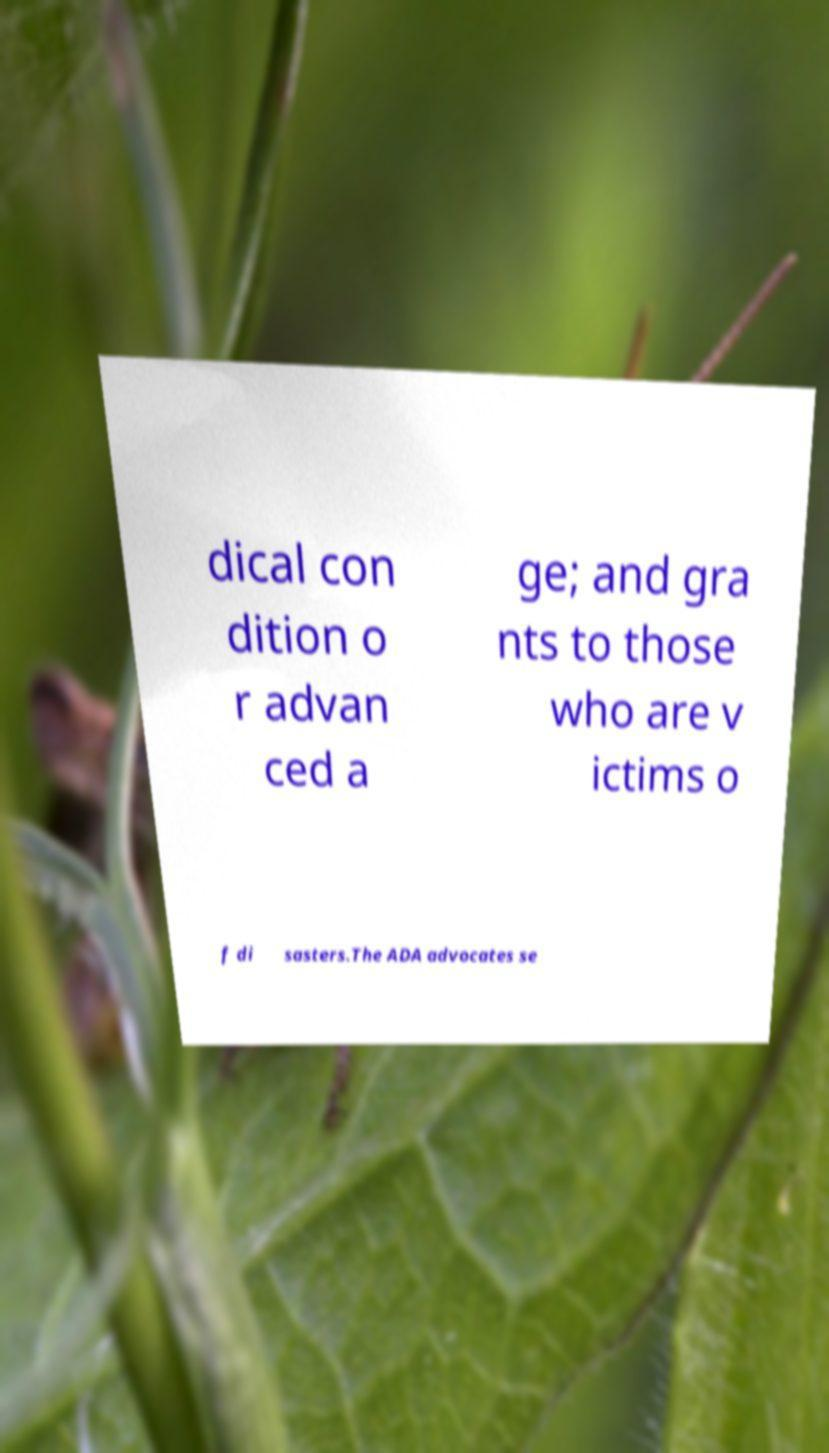Could you extract and type out the text from this image? dical con dition o r advan ced a ge; and gra nts to those who are v ictims o f di sasters.The ADA advocates se 